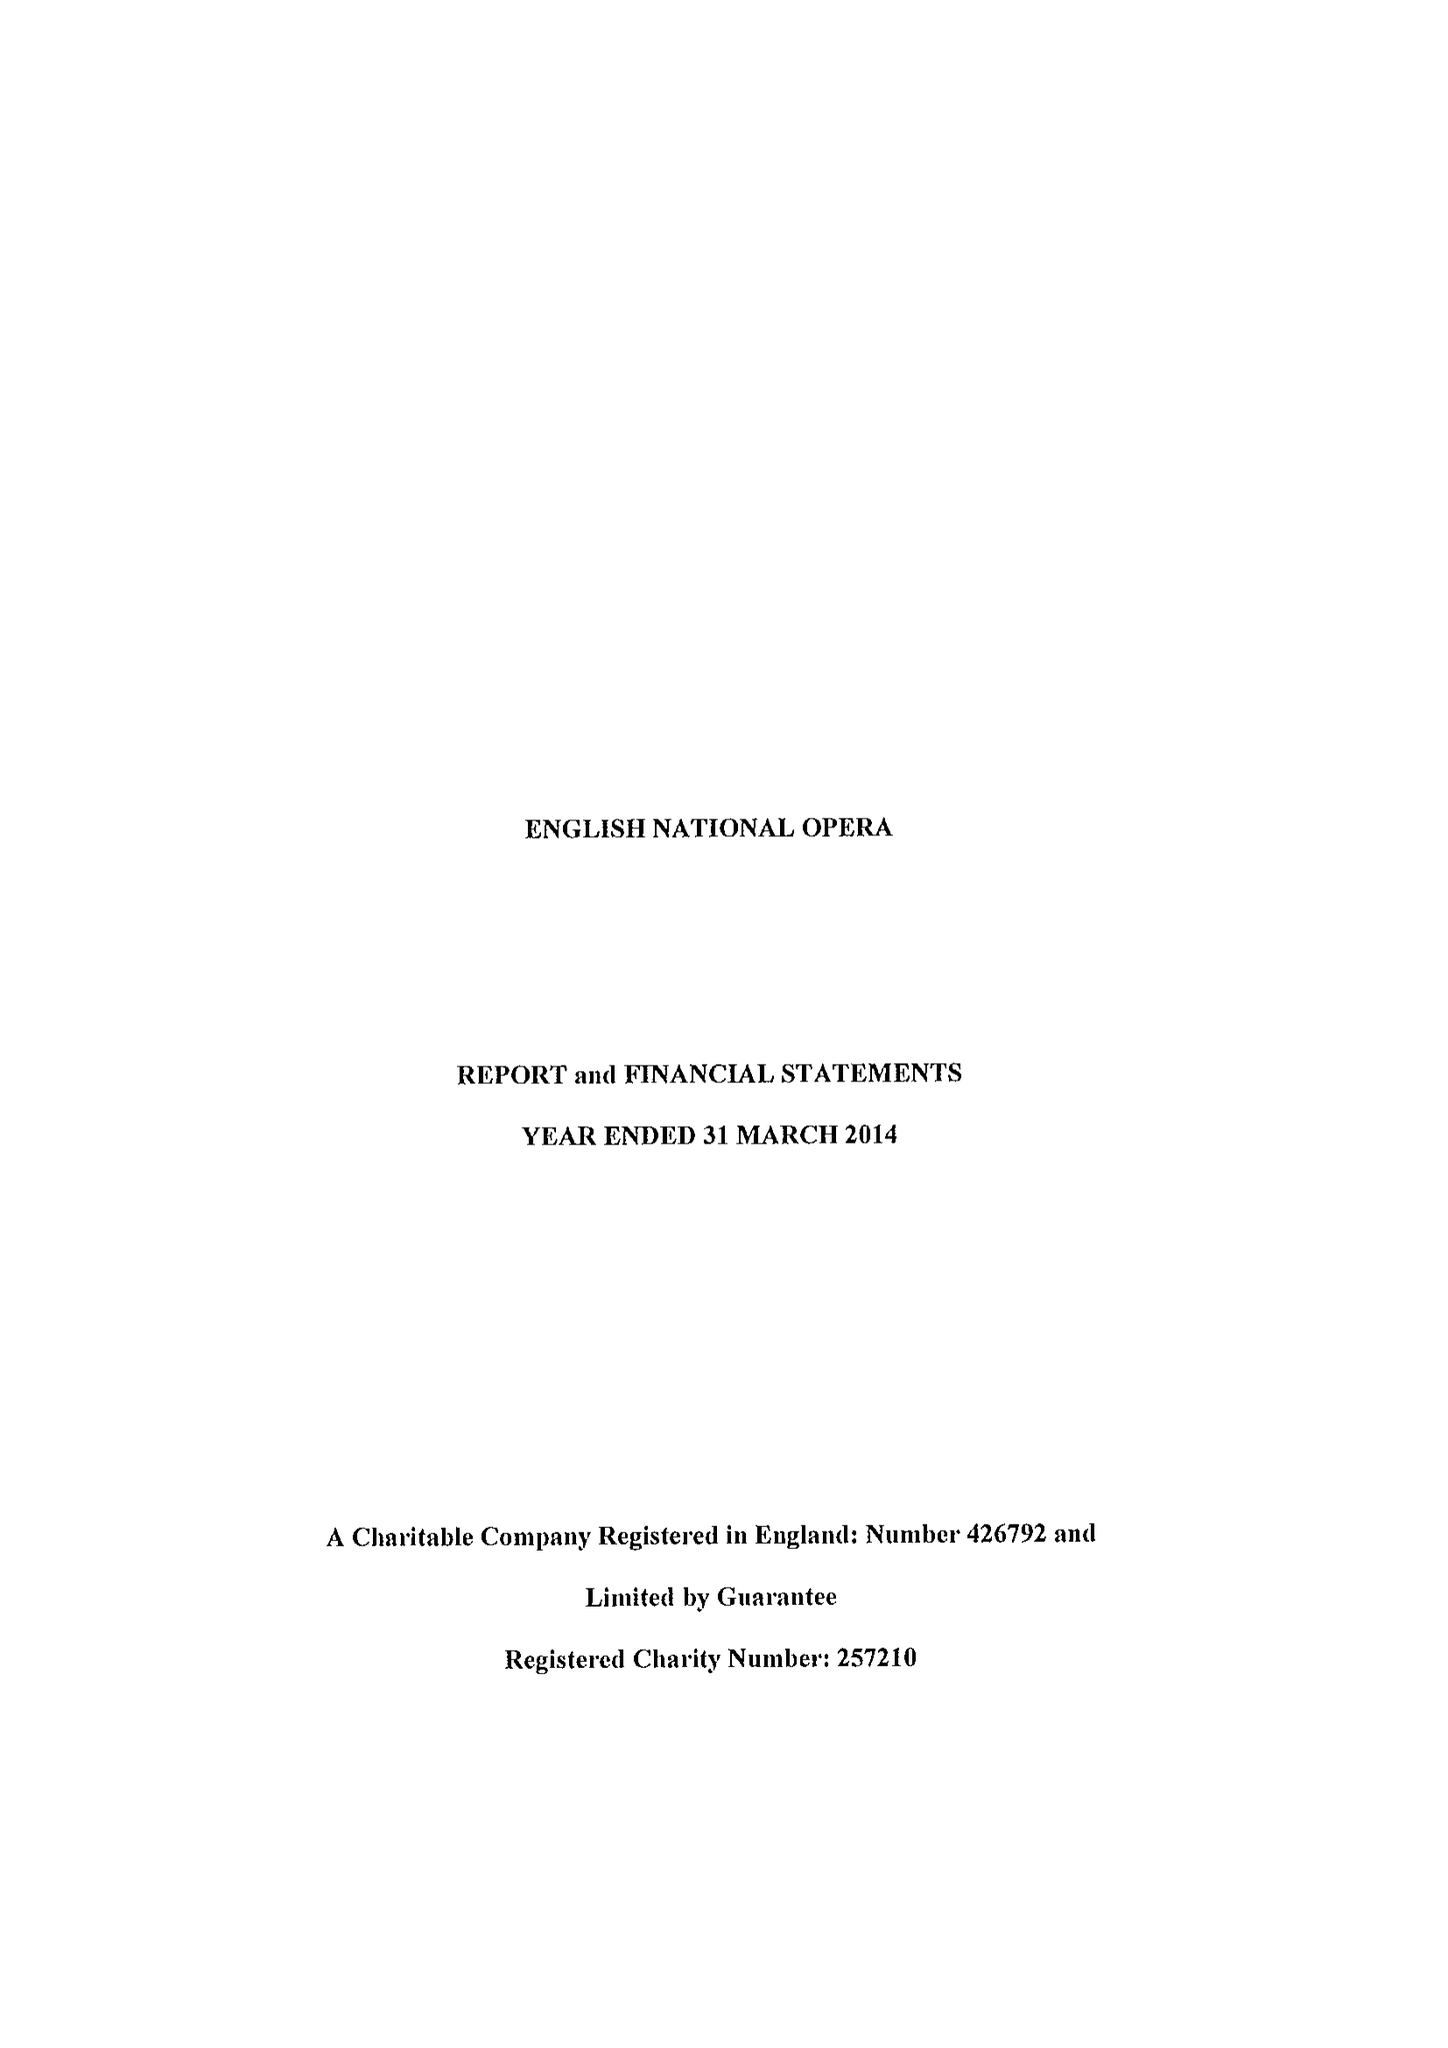What is the value for the report_date?
Answer the question using a single word or phrase. 2014-03-31 